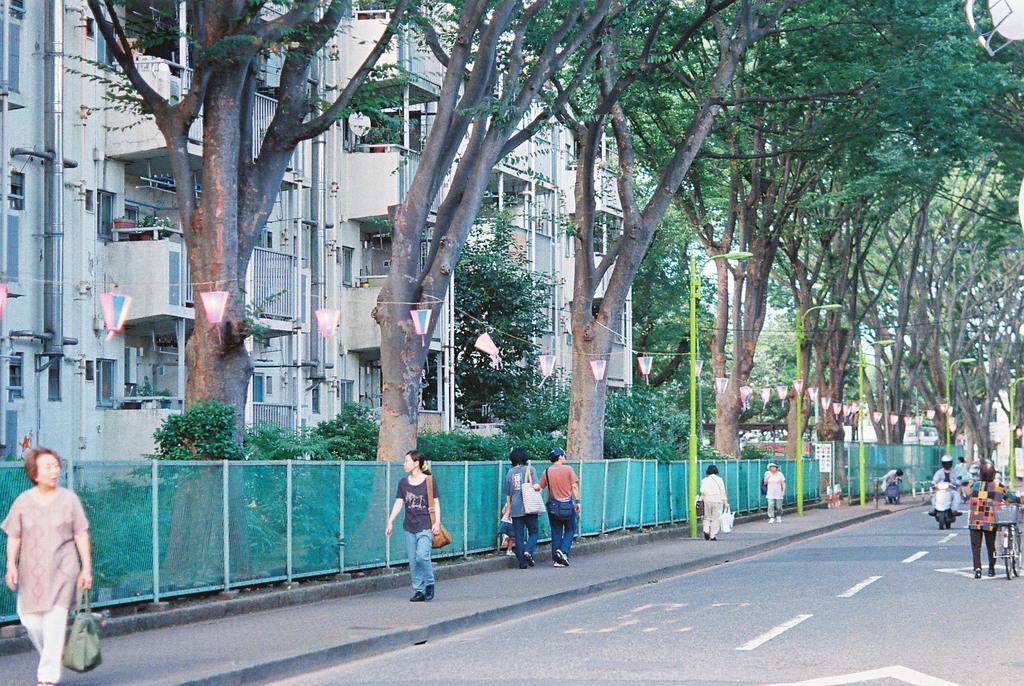Could you give a brief overview of what you see in this image? In this picture we can see some people are walking, a woman in the front is carrying a bag, a person on the right side is holding a bicycle, there is a person riding a scooter, we can see fencing, trees, lights and poles in the middle, in the background there are buildings. 